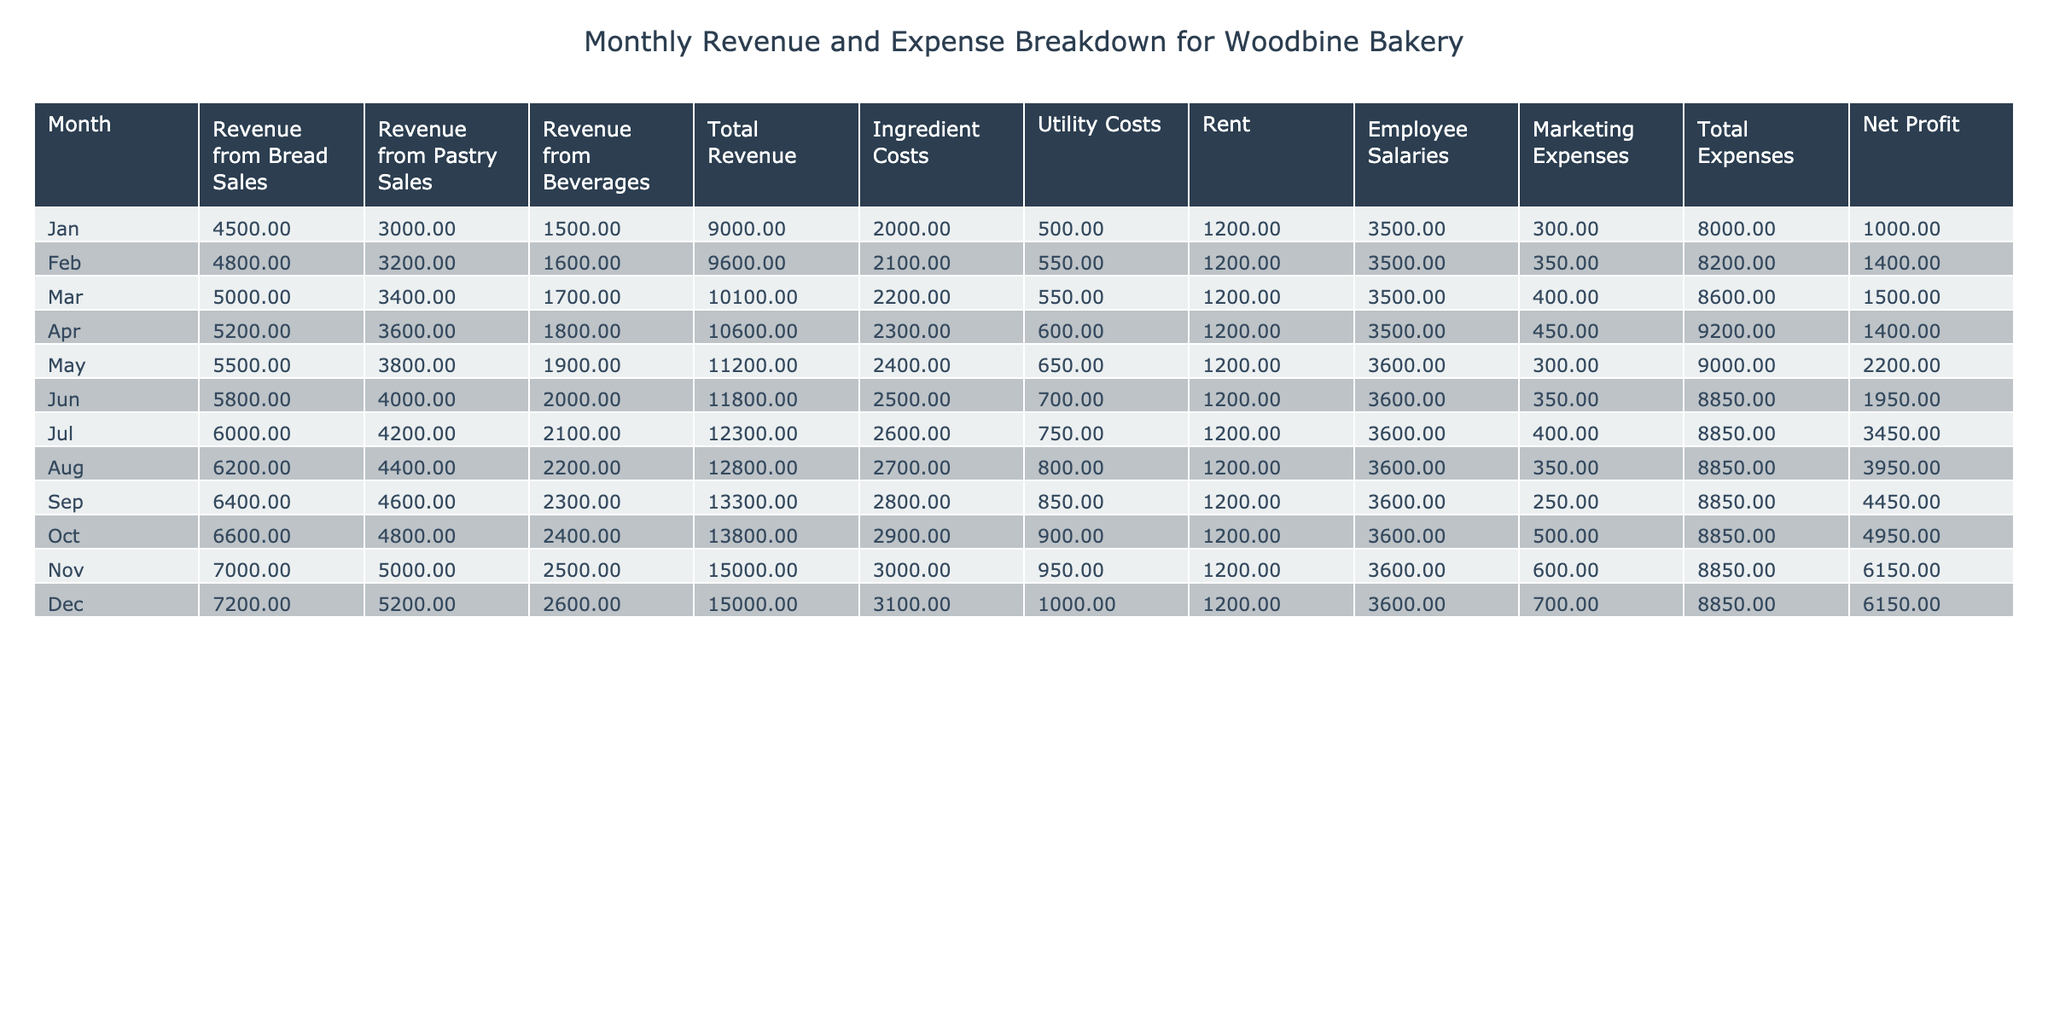What was the total revenue in November? In the table, I can locate the row for November, which shows the Total Revenue for that month. It is listed as 15000.
Answer: 15000 What are the ingredient costs for March? By looking at the row for March, I find the Ingredient Costs listed as 2200.
Answer: 2200 What is the average net profit across all months? First, I need to sum the Net Profit for each month: (1000 + 1400 + 1500 + 1400 + 2200 + 1950 + 3450 + 3950 + 4450 + 4950 + 6150 + 6150) = 30100. There are 12 months, so the average is 30100 / 12 = 2508.33.
Answer: 2508.33 Did the total expenses exceed the total revenue in January? I can check the respective Total Expenses and Total Revenue for January in the table. The Total Revenue is 9000, and the Total Expenses are 8000. Since 8000 is less than 9000, the statement is false.
Answer: No Which month had the highest net profit and what was it? Examining the Net Profit column, I identify the highest value, which occurs in November and is 6150.
Answer: 6150 In which month did the utility costs reach their peak, and what was the amount? By analyzing the Utility Costs column, I see that the maximum value is 1000, which occurs in December.
Answer: December, 1000 What was the total revenue for the bakery from January to June? To find this, I sum the Total Revenue from January (9000) through June (11800): 9000 + 9600 + 10100 + 10600 + 11200 + 11800 = 67300.
Answer: 67300 How much did the rent cost in each month, and what was the total for the year? The rent is consistently 1200 for the first eleven months and 1200 for December. Therefore, the total is: 1200 * 12 = 14400.
Answer: 14400 Was there ever a month where the utility costs were lower than 500? By examining the Utility Costs, I see they started at 500 in January, and the lowest value recorded is 500. Since none fall below that, the answer is false.
Answer: No 